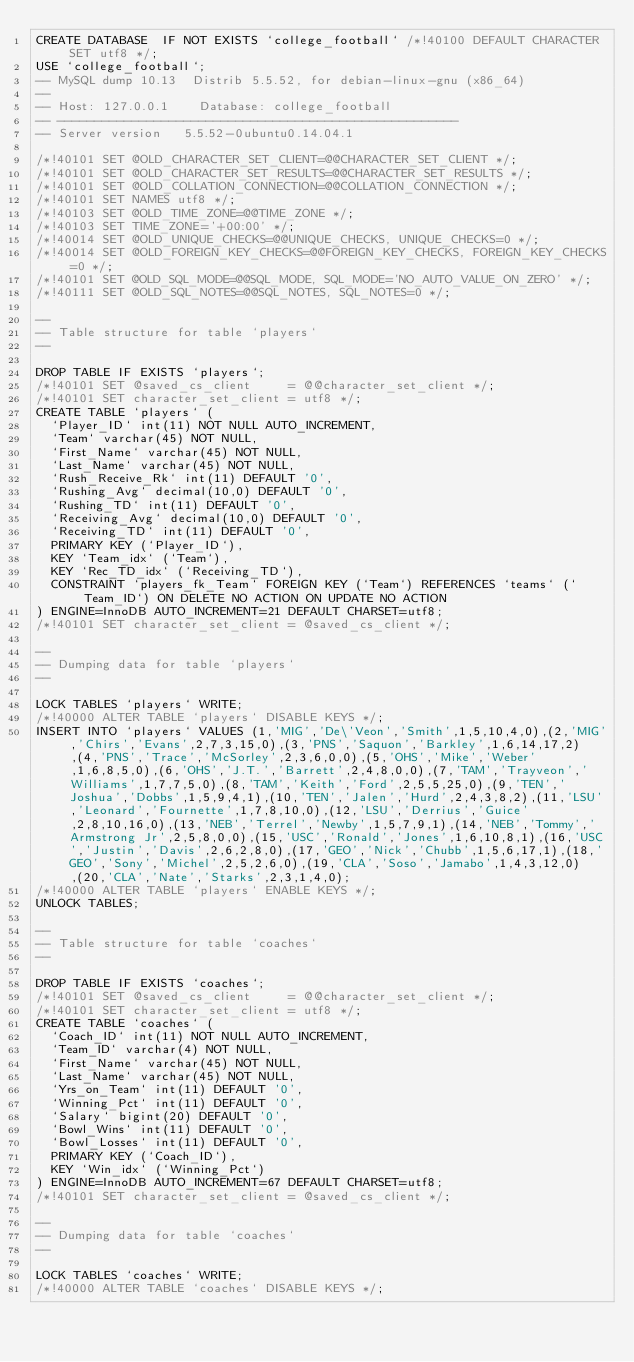Convert code to text. <code><loc_0><loc_0><loc_500><loc_500><_SQL_>CREATE DATABASE  IF NOT EXISTS `college_football` /*!40100 DEFAULT CHARACTER SET utf8 */;
USE `college_football`;
-- MySQL dump 10.13  Distrib 5.5.52, for debian-linux-gnu (x86_64)
--
-- Host: 127.0.0.1    Database: college_football
-- ------------------------------------------------------
-- Server version	5.5.52-0ubuntu0.14.04.1

/*!40101 SET @OLD_CHARACTER_SET_CLIENT=@@CHARACTER_SET_CLIENT */;
/*!40101 SET @OLD_CHARACTER_SET_RESULTS=@@CHARACTER_SET_RESULTS */;
/*!40101 SET @OLD_COLLATION_CONNECTION=@@COLLATION_CONNECTION */;
/*!40101 SET NAMES utf8 */;
/*!40103 SET @OLD_TIME_ZONE=@@TIME_ZONE */;
/*!40103 SET TIME_ZONE='+00:00' */;
/*!40014 SET @OLD_UNIQUE_CHECKS=@@UNIQUE_CHECKS, UNIQUE_CHECKS=0 */;
/*!40014 SET @OLD_FOREIGN_KEY_CHECKS=@@FOREIGN_KEY_CHECKS, FOREIGN_KEY_CHECKS=0 */;
/*!40101 SET @OLD_SQL_MODE=@@SQL_MODE, SQL_MODE='NO_AUTO_VALUE_ON_ZERO' */;
/*!40111 SET @OLD_SQL_NOTES=@@SQL_NOTES, SQL_NOTES=0 */;

--
-- Table structure for table `players`
--

DROP TABLE IF EXISTS `players`;
/*!40101 SET @saved_cs_client     = @@character_set_client */;
/*!40101 SET character_set_client = utf8 */;
CREATE TABLE `players` (
  `Player_ID` int(11) NOT NULL AUTO_INCREMENT,
  `Team` varchar(45) NOT NULL,
  `First_Name` varchar(45) NOT NULL,
  `Last_Name` varchar(45) NOT NULL,
  `Rush_Receive_Rk` int(11) DEFAULT '0',
  `Rushing_Avg` decimal(10,0) DEFAULT '0',
  `Rushing_TD` int(11) DEFAULT '0',
  `Receiving_Avg` decimal(10,0) DEFAULT '0',
  `Receiving_TD` int(11) DEFAULT '0',
  PRIMARY KEY (`Player_ID`),
  KEY `Team_idx` (`Team`),
  KEY `Rec_TD_idx` (`Receiving_TD`),
  CONSTRAINT `players_fk_Team` FOREIGN KEY (`Team`) REFERENCES `teams` (`Team_ID`) ON DELETE NO ACTION ON UPDATE NO ACTION
) ENGINE=InnoDB AUTO_INCREMENT=21 DEFAULT CHARSET=utf8;
/*!40101 SET character_set_client = @saved_cs_client */;

--
-- Dumping data for table `players`
--

LOCK TABLES `players` WRITE;
/*!40000 ALTER TABLE `players` DISABLE KEYS */;
INSERT INTO `players` VALUES (1,'MIG','De\'Veon','Smith',1,5,10,4,0),(2,'MIG','Chirs','Evans',2,7,3,15,0),(3,'PNS','Saquon','Barkley',1,6,14,17,2),(4,'PNS','Trace','McSorley',2,3,6,0,0),(5,'OHS','Mike','Weber',1,6,8,5,0),(6,'OHS','J.T.','Barrett',2,4,8,0,0),(7,'TAM','Trayveon','Williams',1,7,7,5,0),(8,'TAM','Keith','Ford',2,5,5,25,0),(9,'TEN','Joshua','Dobbs',1,5,9,4,1),(10,'TEN','Jalen','Hurd',2,4,3,8,2),(11,'LSU','Leonard','Fournette',1,7,8,10,0),(12,'LSU','Derrius','Guice',2,8,10,16,0),(13,'NEB','Terrel','Newby',1,5,7,9,1),(14,'NEB','Tommy','Armstrong Jr',2,5,8,0,0),(15,'USC','Ronald','Jones',1,6,10,8,1),(16,'USC','Justin','Davis',2,6,2,8,0),(17,'GEO','Nick','Chubb',1,5,6,17,1),(18,'GEO','Sony','Michel',2,5,2,6,0),(19,'CLA','Soso','Jamabo',1,4,3,12,0),(20,'CLA','Nate','Starks',2,3,1,4,0);
/*!40000 ALTER TABLE `players` ENABLE KEYS */;
UNLOCK TABLES;

--
-- Table structure for table `coaches`
--

DROP TABLE IF EXISTS `coaches`;
/*!40101 SET @saved_cs_client     = @@character_set_client */;
/*!40101 SET character_set_client = utf8 */;
CREATE TABLE `coaches` (
  `Coach_ID` int(11) NOT NULL AUTO_INCREMENT,
  `Team_ID` varchar(4) NOT NULL,
  `First_Name` varchar(45) NOT NULL,
  `Last_Name` varchar(45) NOT NULL,
  `Yrs_on_Team` int(11) DEFAULT '0',
  `Winning_Pct` int(11) DEFAULT '0',
  `Salary` bigint(20) DEFAULT '0',
  `Bowl_Wins` int(11) DEFAULT '0',
  `Bowl_Losses` int(11) DEFAULT '0',
  PRIMARY KEY (`Coach_ID`),
  KEY `Win_idx` (`Winning_Pct`)
) ENGINE=InnoDB AUTO_INCREMENT=67 DEFAULT CHARSET=utf8;
/*!40101 SET character_set_client = @saved_cs_client */;

--
-- Dumping data for table `coaches`
--

LOCK TABLES `coaches` WRITE;
/*!40000 ALTER TABLE `coaches` DISABLE KEYS */;</code> 